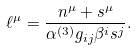<formula> <loc_0><loc_0><loc_500><loc_500>\ell ^ { \mu } = \frac { n ^ { \mu } + s ^ { \mu } } { \alpha ^ { ( 3 ) } g _ { i j } \beta ^ { i } s ^ { j } } .</formula> 